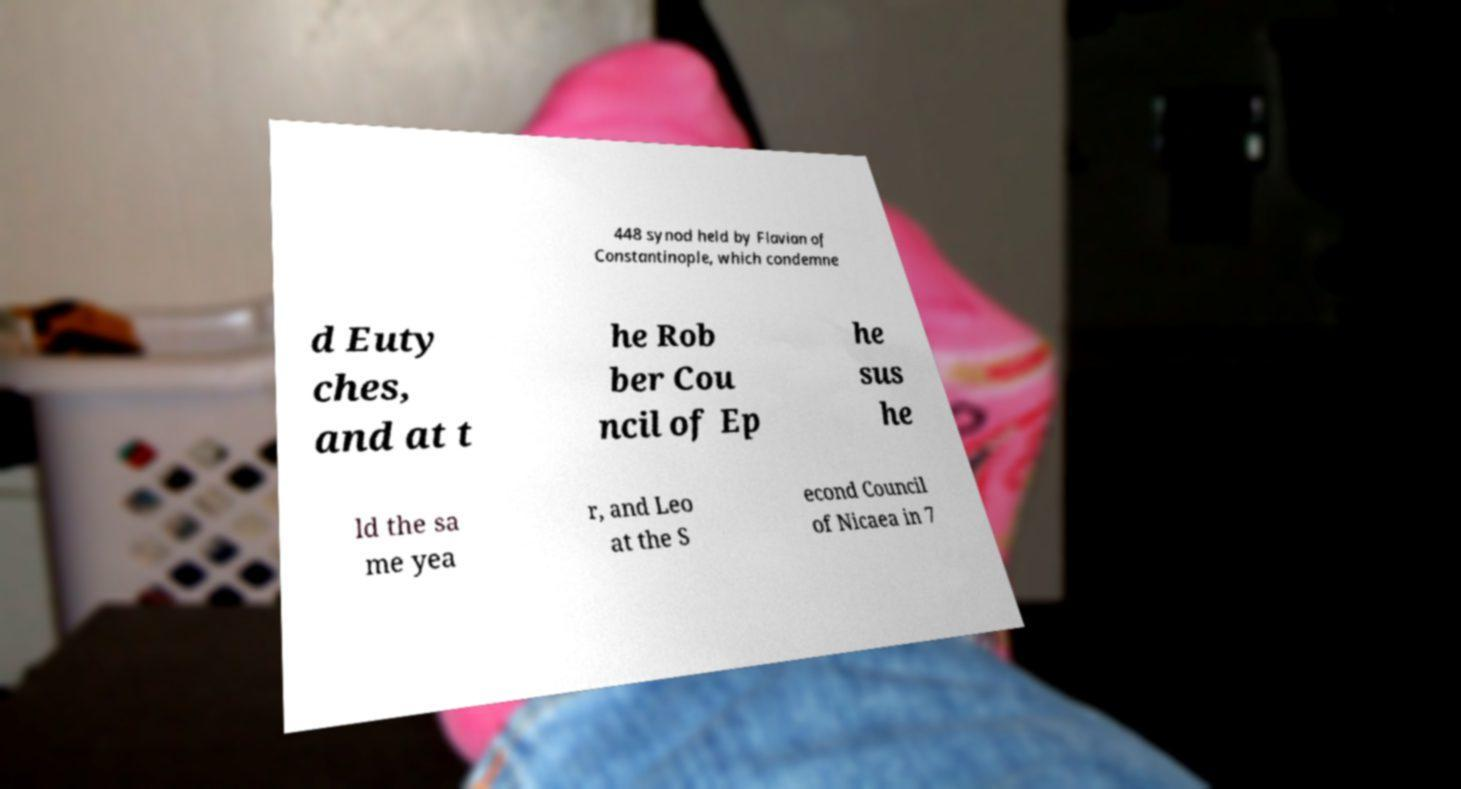Please read and relay the text visible in this image. What does it say? 448 synod held by Flavian of Constantinople, which condemne d Euty ches, and at t he Rob ber Cou ncil of Ep he sus he ld the sa me yea r, and Leo at the S econd Council of Nicaea in 7 